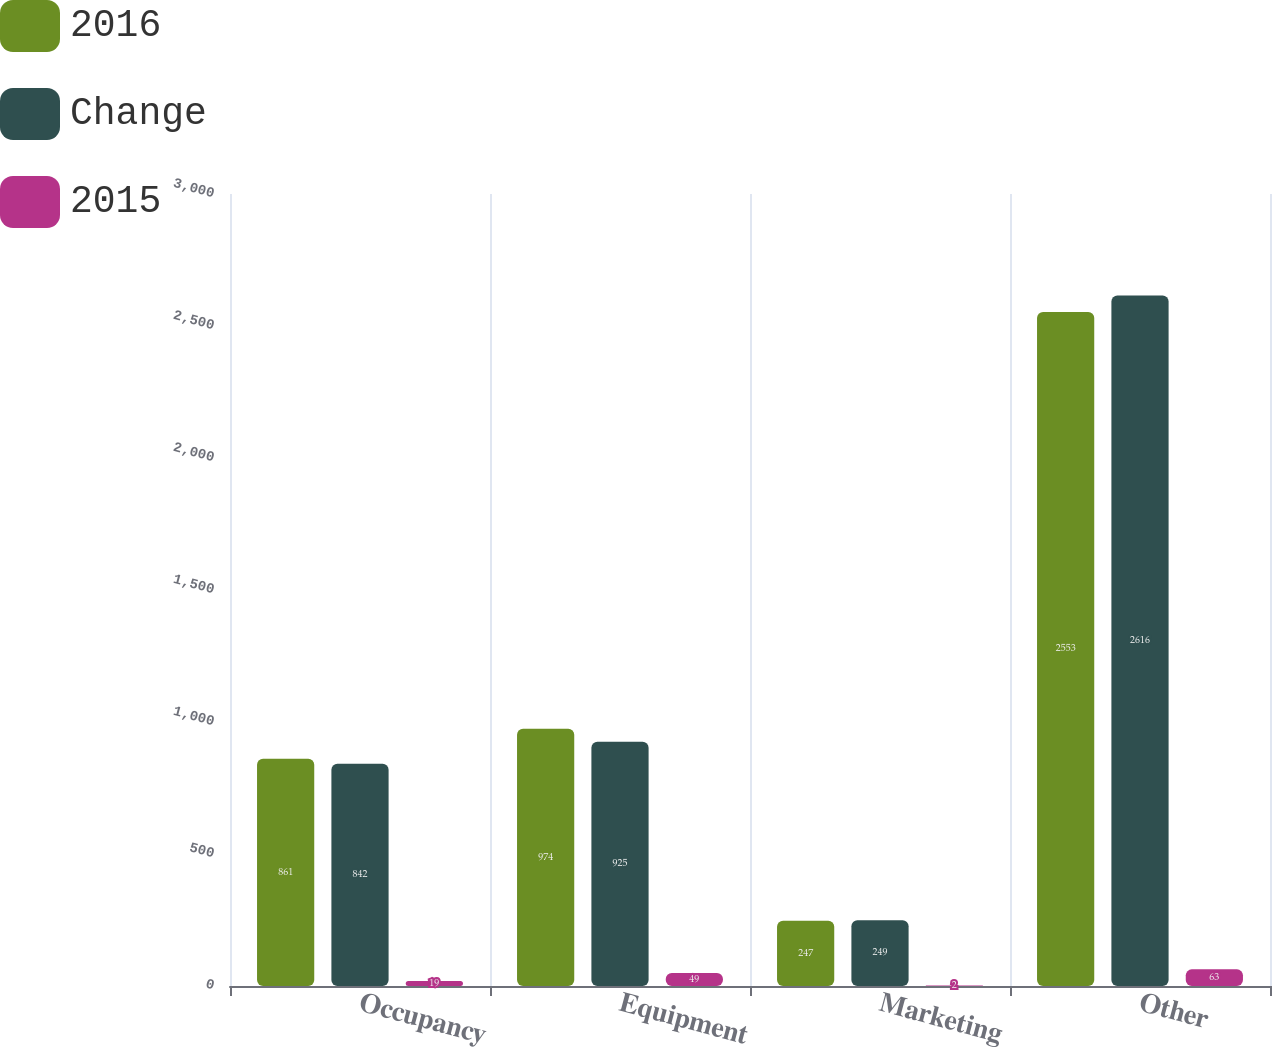Convert chart. <chart><loc_0><loc_0><loc_500><loc_500><stacked_bar_chart><ecel><fcel>Occupancy<fcel>Equipment<fcel>Marketing<fcel>Other<nl><fcel>2016<fcel>861<fcel>974<fcel>247<fcel>2553<nl><fcel>Change<fcel>842<fcel>925<fcel>249<fcel>2616<nl><fcel>2015<fcel>19<fcel>49<fcel>2<fcel>63<nl></chart> 